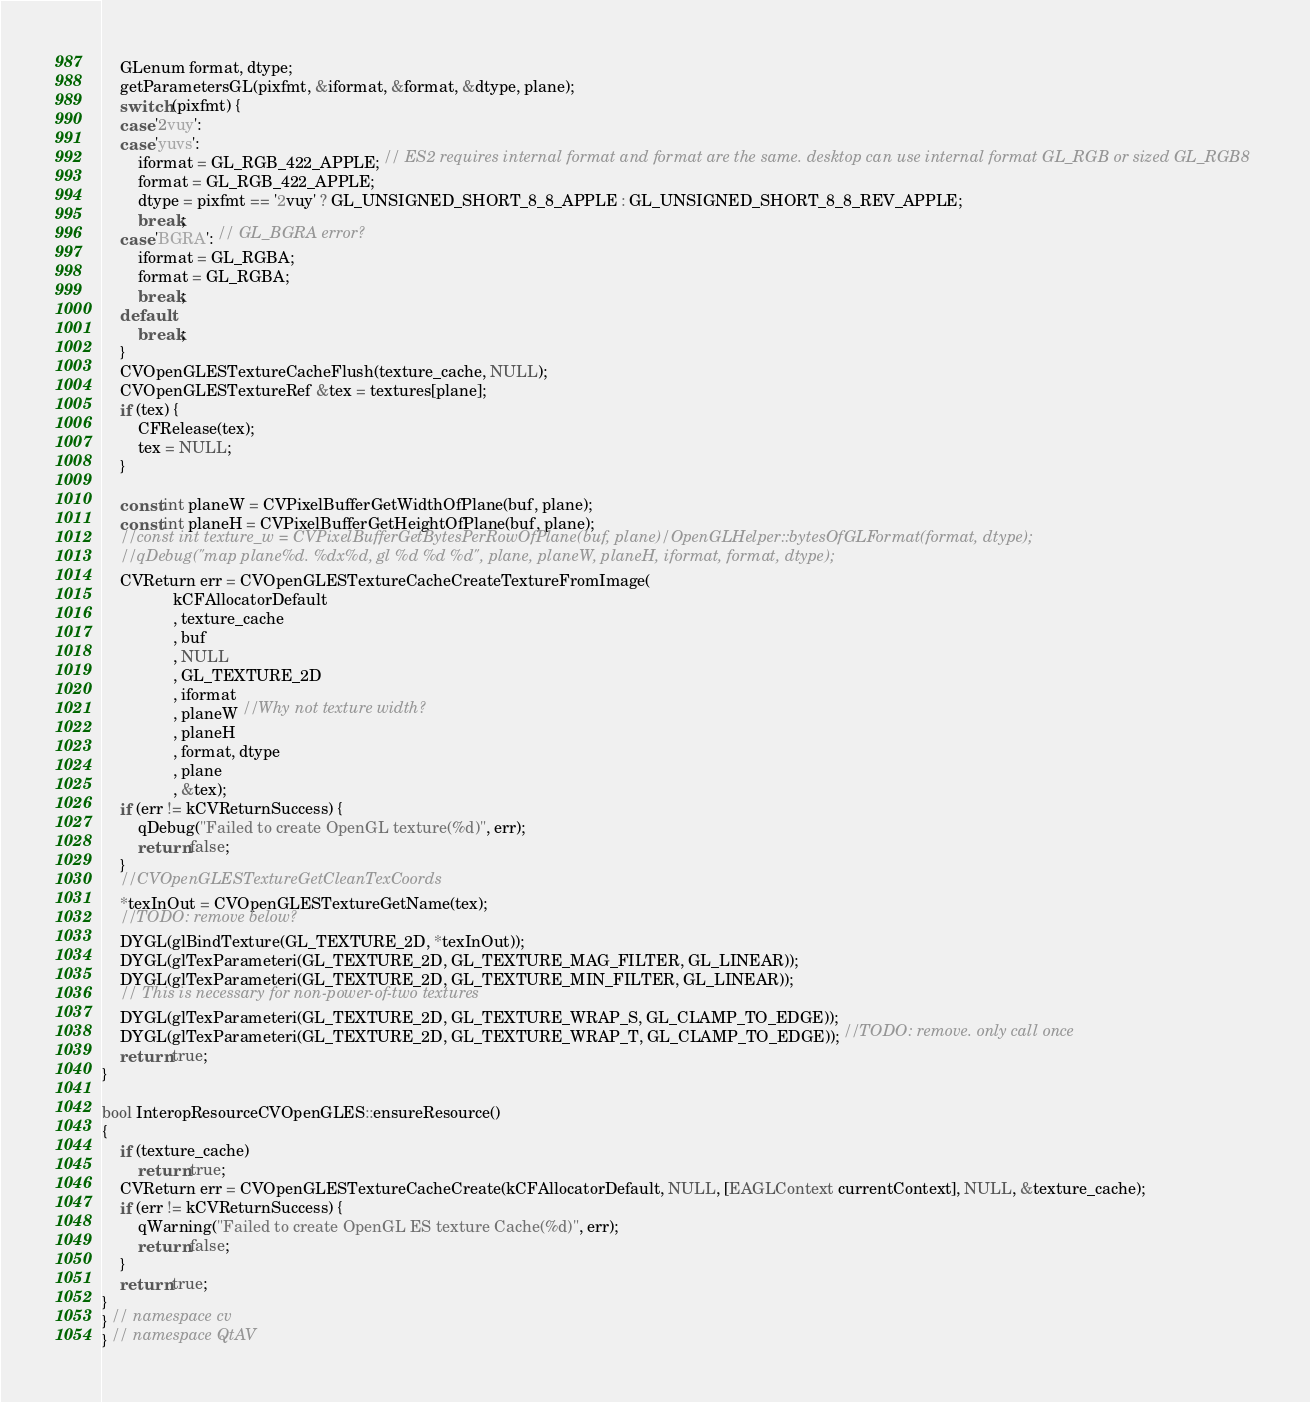<code> <loc_0><loc_0><loc_500><loc_500><_ObjectiveC_>    GLenum format, dtype;
    getParametersGL(pixfmt, &iformat, &format, &dtype, plane);
    switch (pixfmt) {
    case '2vuy':
    case 'yuvs':
        iformat = GL_RGB_422_APPLE; // ES2 requires internal format and format are the same. desktop can use internal format GL_RGB or sized GL_RGB8
        format = GL_RGB_422_APPLE;
        dtype = pixfmt == '2vuy' ? GL_UNSIGNED_SHORT_8_8_APPLE : GL_UNSIGNED_SHORT_8_8_REV_APPLE;
        break;
    case 'BGRA': // GL_BGRA error?
        iformat = GL_RGBA;
        format = GL_RGBA;
        break;
    default:
        break;
    }
    CVOpenGLESTextureCacheFlush(texture_cache, NULL);
    CVOpenGLESTextureRef &tex = textures[plane];
    if (tex) {
        CFRelease(tex);
        tex = NULL;
    }

    const int planeW = CVPixelBufferGetWidthOfPlane(buf, plane);
    const int planeH = CVPixelBufferGetHeightOfPlane(buf, plane);
    //const int texture_w = CVPixelBufferGetBytesPerRowOfPlane(buf, plane)/OpenGLHelper::bytesOfGLFormat(format, dtype);
    //qDebug("map plane%d. %dx%d, gl %d %d %d", plane, planeW, planeH, iformat, format, dtype);
    CVReturn err = CVOpenGLESTextureCacheCreateTextureFromImage(
                kCFAllocatorDefault
                , texture_cache
                , buf
                , NULL
                , GL_TEXTURE_2D
                , iformat
                , planeW //Why not texture width?
                , planeH
                , format, dtype
                , plane
                , &tex);
    if (err != kCVReturnSuccess) {
        qDebug("Failed to create OpenGL texture(%d)", err);
        return false;
    }
    //CVOpenGLESTextureGetCleanTexCoords
    *texInOut = CVOpenGLESTextureGetName(tex);
    //TODO: remove below?
    DYGL(glBindTexture(GL_TEXTURE_2D, *texInOut));
    DYGL(glTexParameteri(GL_TEXTURE_2D, GL_TEXTURE_MAG_FILTER, GL_LINEAR));
    DYGL(glTexParameteri(GL_TEXTURE_2D, GL_TEXTURE_MIN_FILTER, GL_LINEAR));
    // This is necessary for non-power-of-two textures
    DYGL(glTexParameteri(GL_TEXTURE_2D, GL_TEXTURE_WRAP_S, GL_CLAMP_TO_EDGE));
    DYGL(glTexParameteri(GL_TEXTURE_2D, GL_TEXTURE_WRAP_T, GL_CLAMP_TO_EDGE)); //TODO: remove. only call once
    return true;
}

bool InteropResourceCVOpenGLES::ensureResource()
{
    if (texture_cache)
        return true;
    CVReturn err = CVOpenGLESTextureCacheCreate(kCFAllocatorDefault, NULL, [EAGLContext currentContext], NULL, &texture_cache);
    if (err != kCVReturnSuccess) {
        qWarning("Failed to create OpenGL ES texture Cache(%d)", err);
        return false;
    }
    return true;
}
} // namespace cv
} // namespace QtAV
</code> 